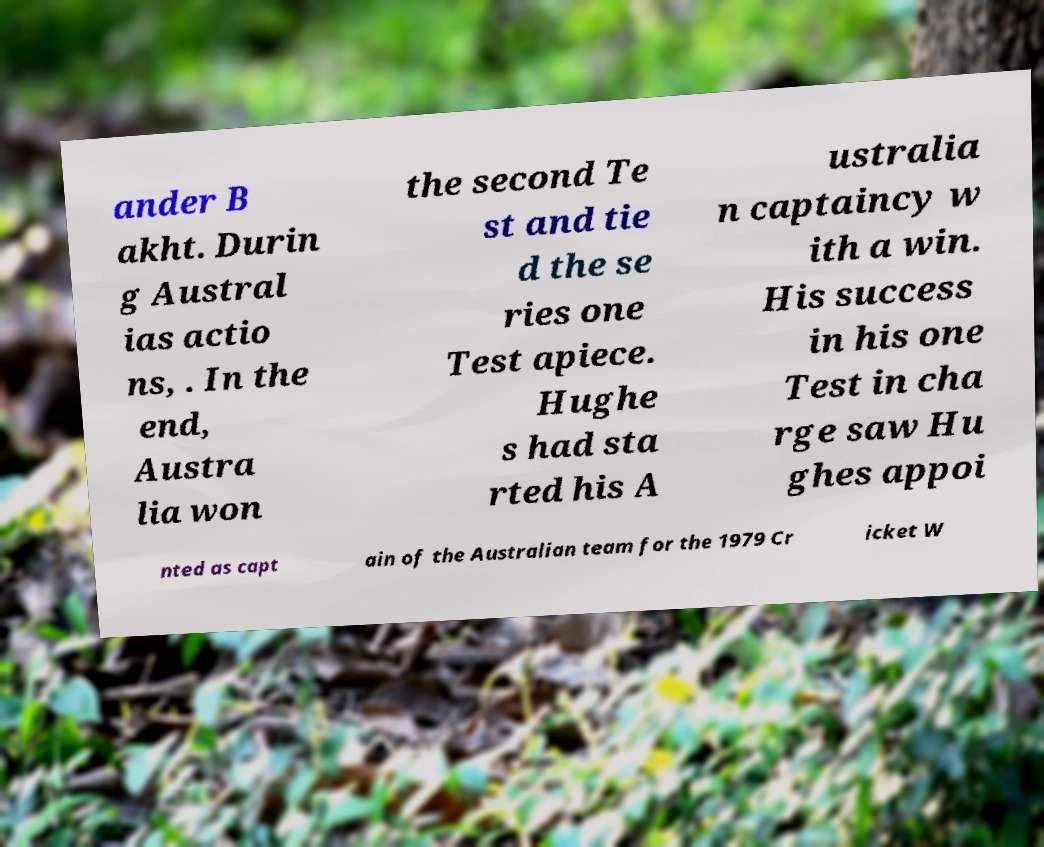There's text embedded in this image that I need extracted. Can you transcribe it verbatim? ander B akht. Durin g Austral ias actio ns, . In the end, Austra lia won the second Te st and tie d the se ries one Test apiece. Hughe s had sta rted his A ustralia n captaincy w ith a win. His success in his one Test in cha rge saw Hu ghes appoi nted as capt ain of the Australian team for the 1979 Cr icket W 